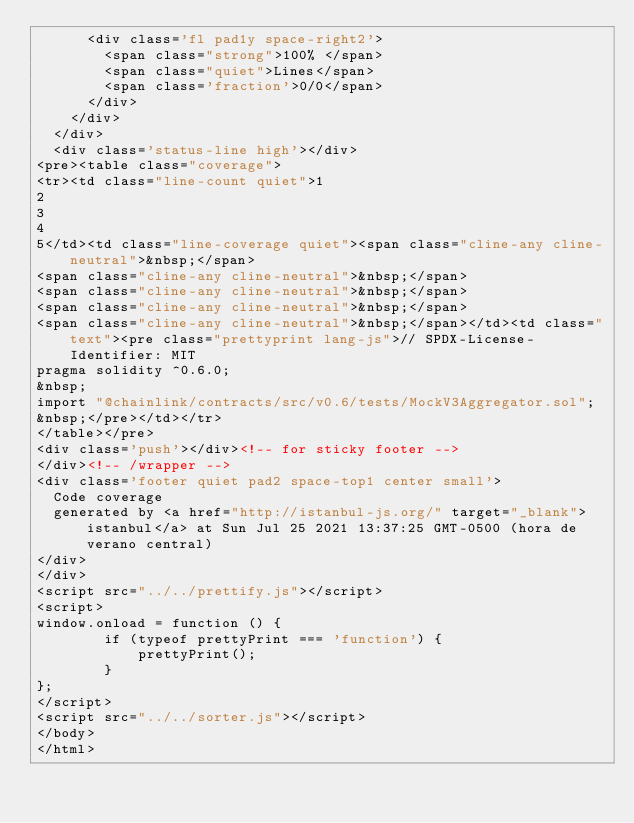Convert code to text. <code><loc_0><loc_0><loc_500><loc_500><_HTML_>      <div class='fl pad1y space-right2'>
        <span class="strong">100% </span>
        <span class="quiet">Lines</span>
        <span class='fraction'>0/0</span>
      </div>
    </div>
  </div>
  <div class='status-line high'></div>
<pre><table class="coverage">
<tr><td class="line-count quiet">1
2
3
4
5</td><td class="line-coverage quiet"><span class="cline-any cline-neutral">&nbsp;</span>
<span class="cline-any cline-neutral">&nbsp;</span>
<span class="cline-any cline-neutral">&nbsp;</span>
<span class="cline-any cline-neutral">&nbsp;</span>
<span class="cline-any cline-neutral">&nbsp;</span></td><td class="text"><pre class="prettyprint lang-js">// SPDX-License-Identifier: MIT
pragma solidity ^0.6.0;
&nbsp;
import "@chainlink/contracts/src/v0.6/tests/MockV3Aggregator.sol";
&nbsp;</pre></td></tr>
</table></pre>
<div class='push'></div><!-- for sticky footer -->
</div><!-- /wrapper -->
<div class='footer quiet pad2 space-top1 center small'>
  Code coverage
  generated by <a href="http://istanbul-js.org/" target="_blank">istanbul</a> at Sun Jul 25 2021 13:37:25 GMT-0500 (hora de verano central)
</div>
</div>
<script src="../../prettify.js"></script>
<script>
window.onload = function () {
        if (typeof prettyPrint === 'function') {
            prettyPrint();
        }
};
</script>
<script src="../../sorter.js"></script>
</body>
</html>
</code> 